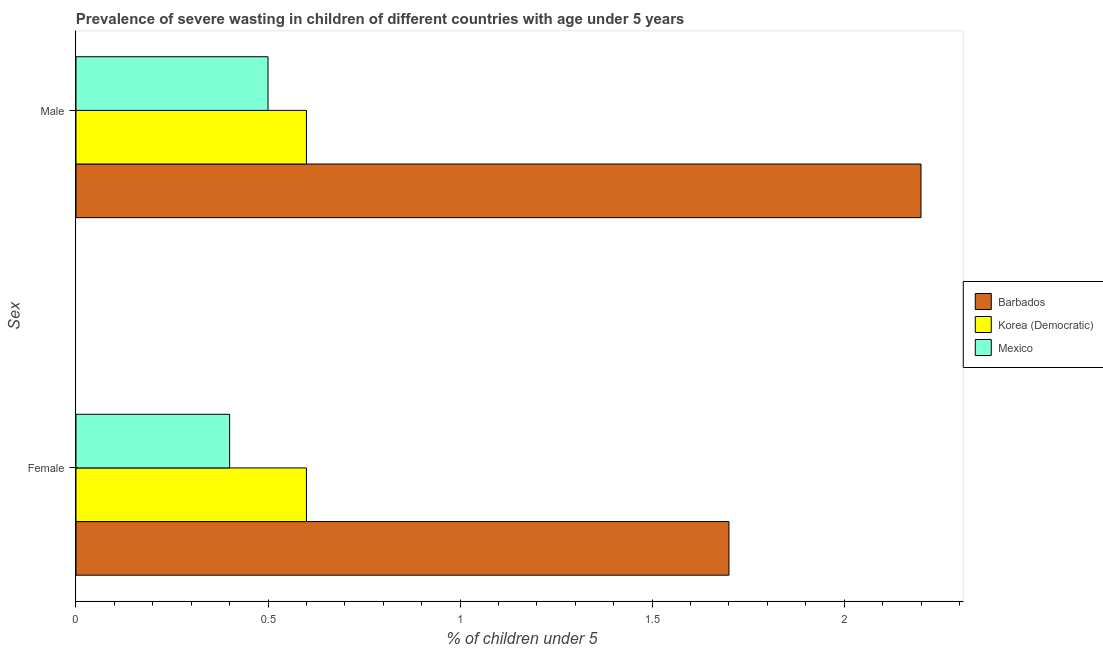How many different coloured bars are there?
Ensure brevity in your answer.  3. Are the number of bars per tick equal to the number of legend labels?
Make the answer very short. Yes. Are the number of bars on each tick of the Y-axis equal?
Offer a very short reply. Yes. What is the label of the 2nd group of bars from the top?
Your response must be concise. Female. What is the percentage of undernourished male children in Mexico?
Offer a terse response. 0.5. Across all countries, what is the maximum percentage of undernourished male children?
Offer a very short reply. 2.2. Across all countries, what is the minimum percentage of undernourished male children?
Your answer should be compact. 0.5. In which country was the percentage of undernourished male children maximum?
Your answer should be compact. Barbados. In which country was the percentage of undernourished female children minimum?
Make the answer very short. Mexico. What is the total percentage of undernourished male children in the graph?
Provide a short and direct response. 3.3. What is the difference between the percentage of undernourished female children in Mexico and that in Korea (Democratic)?
Make the answer very short. -0.2. What is the difference between the percentage of undernourished female children in Barbados and the percentage of undernourished male children in Korea (Democratic)?
Offer a very short reply. 1.1. What is the average percentage of undernourished male children per country?
Your response must be concise. 1.1. What is the difference between the percentage of undernourished female children and percentage of undernourished male children in Korea (Democratic)?
Your answer should be very brief. 0. What is the ratio of the percentage of undernourished male children in Korea (Democratic) to that in Barbados?
Offer a very short reply. 0.27. Is the percentage of undernourished male children in Korea (Democratic) less than that in Barbados?
Offer a terse response. Yes. What does the 1st bar from the bottom in Female represents?
Your answer should be compact. Barbados. How many countries are there in the graph?
Ensure brevity in your answer.  3. What is the difference between two consecutive major ticks on the X-axis?
Keep it short and to the point. 0.5. Are the values on the major ticks of X-axis written in scientific E-notation?
Ensure brevity in your answer.  No. Does the graph contain any zero values?
Ensure brevity in your answer.  No. Where does the legend appear in the graph?
Give a very brief answer. Center right. What is the title of the graph?
Your answer should be compact. Prevalence of severe wasting in children of different countries with age under 5 years. Does "Rwanda" appear as one of the legend labels in the graph?
Your answer should be very brief. No. What is the label or title of the X-axis?
Offer a very short reply.  % of children under 5. What is the label or title of the Y-axis?
Make the answer very short. Sex. What is the  % of children under 5 in Barbados in Female?
Keep it short and to the point. 1.7. What is the  % of children under 5 in Korea (Democratic) in Female?
Ensure brevity in your answer.  0.6. What is the  % of children under 5 in Mexico in Female?
Keep it short and to the point. 0.4. What is the  % of children under 5 in Barbados in Male?
Ensure brevity in your answer.  2.2. What is the  % of children under 5 of Korea (Democratic) in Male?
Ensure brevity in your answer.  0.6. Across all Sex, what is the maximum  % of children under 5 in Barbados?
Make the answer very short. 2.2. Across all Sex, what is the maximum  % of children under 5 of Korea (Democratic)?
Offer a very short reply. 0.6. Across all Sex, what is the minimum  % of children under 5 of Barbados?
Your answer should be compact. 1.7. Across all Sex, what is the minimum  % of children under 5 of Korea (Democratic)?
Give a very brief answer. 0.6. Across all Sex, what is the minimum  % of children under 5 in Mexico?
Provide a short and direct response. 0.4. What is the total  % of children under 5 of Korea (Democratic) in the graph?
Your answer should be very brief. 1.2. What is the total  % of children under 5 of Mexico in the graph?
Provide a succinct answer. 0.9. What is the difference between the  % of children under 5 of Barbados in Female and that in Male?
Provide a succinct answer. -0.5. What is the difference between the  % of children under 5 in Mexico in Female and that in Male?
Your answer should be very brief. -0.1. What is the difference between the  % of children under 5 in Barbados in Female and the  % of children under 5 in Korea (Democratic) in Male?
Offer a very short reply. 1.1. What is the difference between the  % of children under 5 in Barbados in Female and the  % of children under 5 in Mexico in Male?
Offer a terse response. 1.2. What is the average  % of children under 5 of Barbados per Sex?
Keep it short and to the point. 1.95. What is the average  % of children under 5 of Mexico per Sex?
Provide a succinct answer. 0.45. What is the difference between the  % of children under 5 of Barbados and  % of children under 5 of Korea (Democratic) in Female?
Offer a very short reply. 1.1. What is the difference between the  % of children under 5 of Barbados and  % of children under 5 of Mexico in Female?
Keep it short and to the point. 1.3. What is the difference between the  % of children under 5 in Korea (Democratic) and  % of children under 5 in Mexico in Female?
Your answer should be very brief. 0.2. What is the difference between the  % of children under 5 of Korea (Democratic) and  % of children under 5 of Mexico in Male?
Give a very brief answer. 0.1. What is the ratio of the  % of children under 5 in Barbados in Female to that in Male?
Give a very brief answer. 0.77. What is the difference between the highest and the second highest  % of children under 5 in Barbados?
Make the answer very short. 0.5. What is the difference between the highest and the lowest  % of children under 5 of Mexico?
Give a very brief answer. 0.1. 